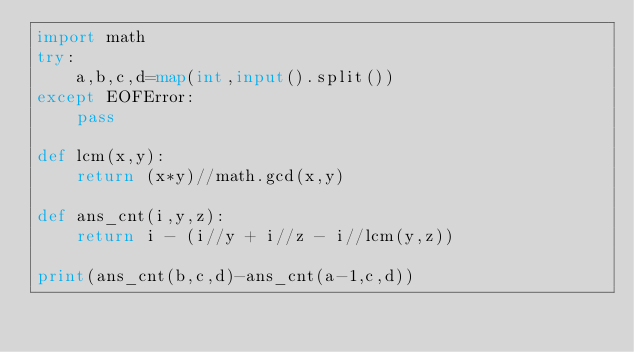<code> <loc_0><loc_0><loc_500><loc_500><_Python_>import math
try:
    a,b,c,d=map(int,input().split())
except EOFError:
    pass

def lcm(x,y):
    return (x*y)//math.gcd(x,y)

def ans_cnt(i,y,z):
    return i - (i//y + i//z - i//lcm(y,z))

print(ans_cnt(b,c,d)-ans_cnt(a-1,c,d))</code> 